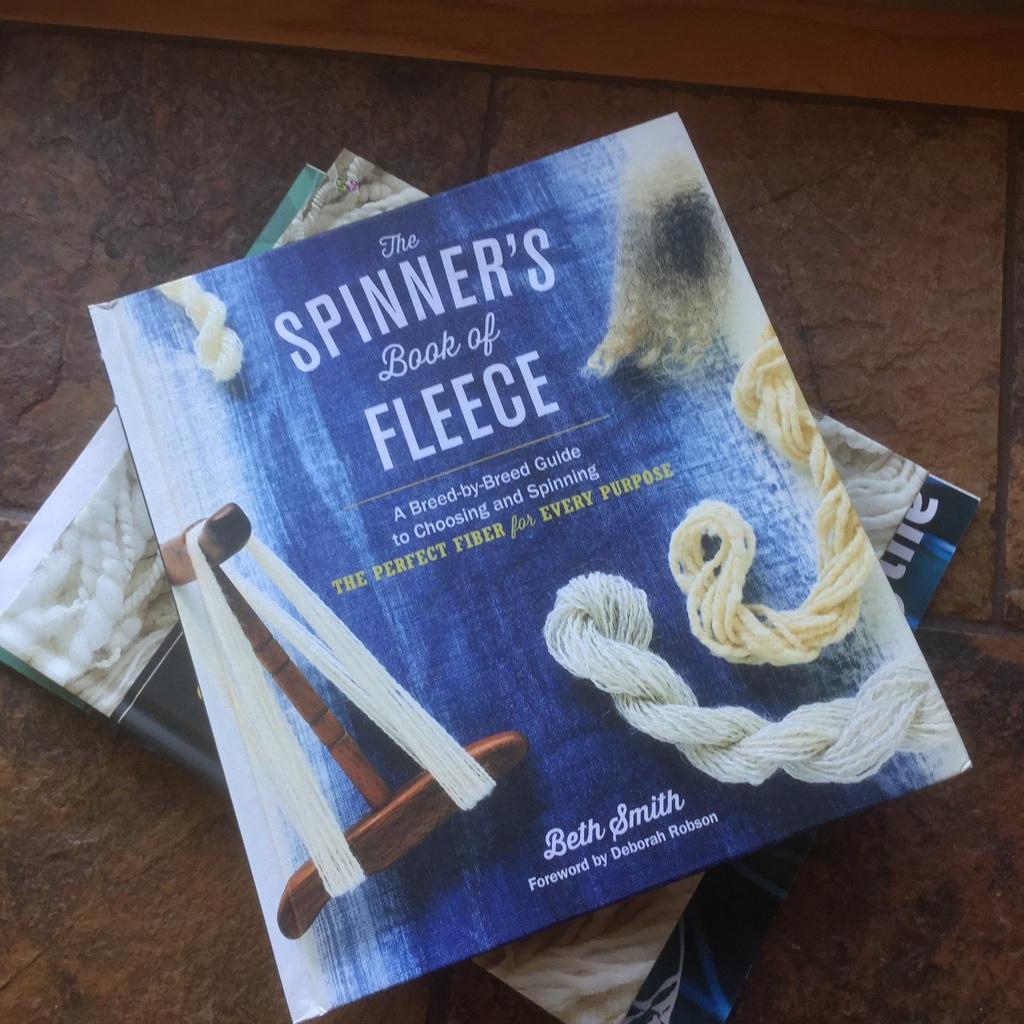Who wrote this book?
Provide a succinct answer. Beth smith. This is the book of what?
Provide a short and direct response. Fleece. 